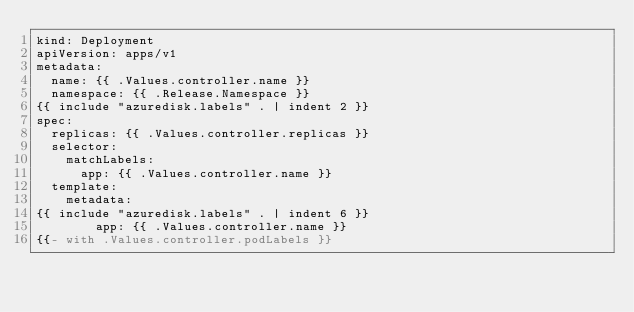<code> <loc_0><loc_0><loc_500><loc_500><_YAML_>kind: Deployment
apiVersion: apps/v1
metadata:
  name: {{ .Values.controller.name }}
  namespace: {{ .Release.Namespace }}
{{ include "azuredisk.labels" . | indent 2 }}
spec:
  replicas: {{ .Values.controller.replicas }}
  selector:
    matchLabels:
      app: {{ .Values.controller.name }}
  template:
    metadata:
{{ include "azuredisk.labels" . | indent 6 }}
        app: {{ .Values.controller.name }}
{{- with .Values.controller.podLabels }}</code> 